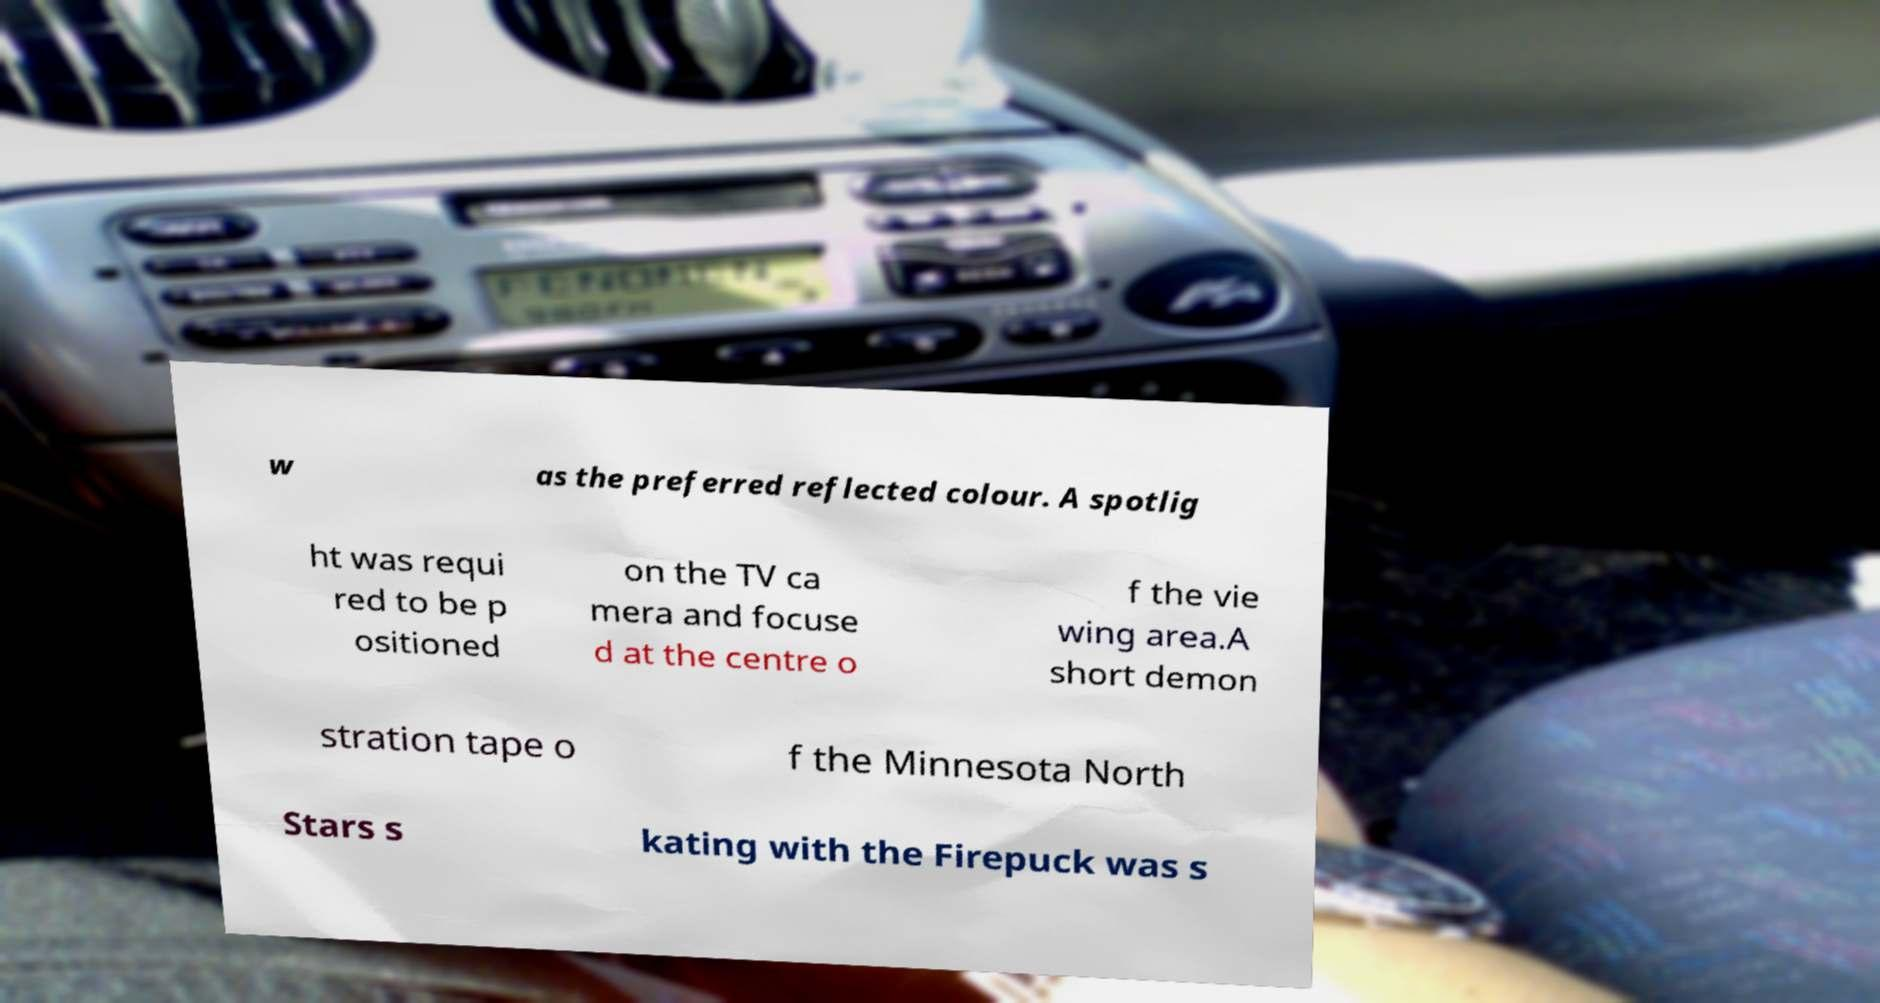There's text embedded in this image that I need extracted. Can you transcribe it verbatim? w as the preferred reflected colour. A spotlig ht was requi red to be p ositioned on the TV ca mera and focuse d at the centre o f the vie wing area.A short demon stration tape o f the Minnesota North Stars s kating with the Firepuck was s 